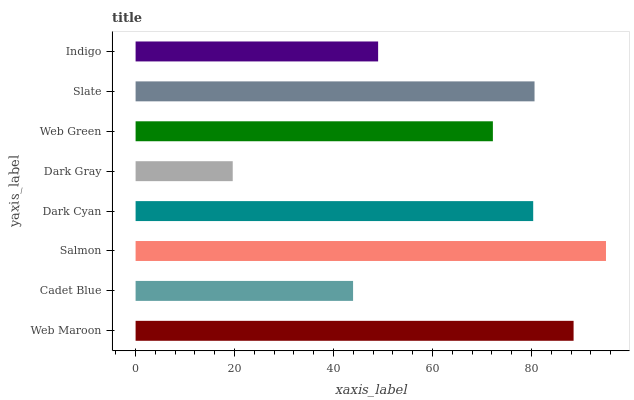Is Dark Gray the minimum?
Answer yes or no. Yes. Is Salmon the maximum?
Answer yes or no. Yes. Is Cadet Blue the minimum?
Answer yes or no. No. Is Cadet Blue the maximum?
Answer yes or no. No. Is Web Maroon greater than Cadet Blue?
Answer yes or no. Yes. Is Cadet Blue less than Web Maroon?
Answer yes or no. Yes. Is Cadet Blue greater than Web Maroon?
Answer yes or no. No. Is Web Maroon less than Cadet Blue?
Answer yes or no. No. Is Dark Cyan the high median?
Answer yes or no. Yes. Is Web Green the low median?
Answer yes or no. Yes. Is Slate the high median?
Answer yes or no. No. Is Salmon the low median?
Answer yes or no. No. 